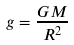Convert formula to latex. <formula><loc_0><loc_0><loc_500><loc_500>g = \frac { G M } { R ^ { 2 } }</formula> 